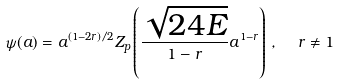Convert formula to latex. <formula><loc_0><loc_0><loc_500><loc_500>\psi ( a ) = a ^ { ( 1 - 2 r ) / 2 } Z _ { p } \left ( \frac { \sqrt { 2 4 E } } { 1 - r } a ^ { 1 - r } \right ) \, , \ \ r \neq 1</formula> 